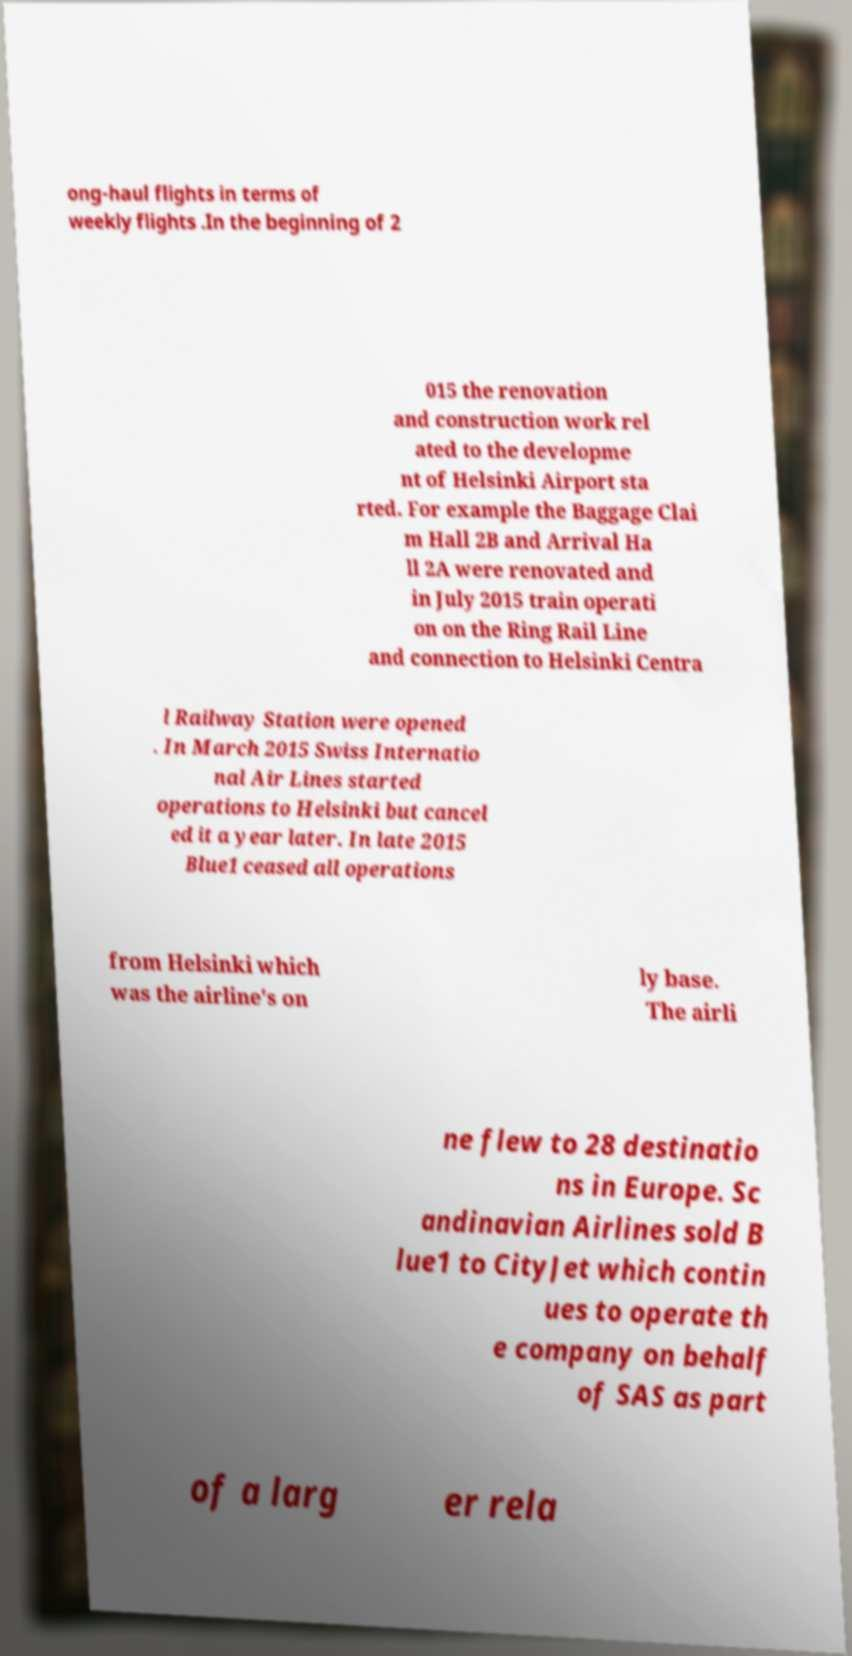There's text embedded in this image that I need extracted. Can you transcribe it verbatim? ong-haul flights in terms of weekly flights .In the beginning of 2 015 the renovation and construction work rel ated to the developme nt of Helsinki Airport sta rted. For example the Baggage Clai m Hall 2B and Arrival Ha ll 2A were renovated and in July 2015 train operati on on the Ring Rail Line and connection to Helsinki Centra l Railway Station were opened . In March 2015 Swiss Internatio nal Air Lines started operations to Helsinki but cancel ed it a year later. In late 2015 Blue1 ceased all operations from Helsinki which was the airline's on ly base. The airli ne flew to 28 destinatio ns in Europe. Sc andinavian Airlines sold B lue1 to CityJet which contin ues to operate th e company on behalf of SAS as part of a larg er rela 